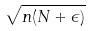<formula> <loc_0><loc_0><loc_500><loc_500>\sqrt { n ( N + \epsilon ) }</formula> 